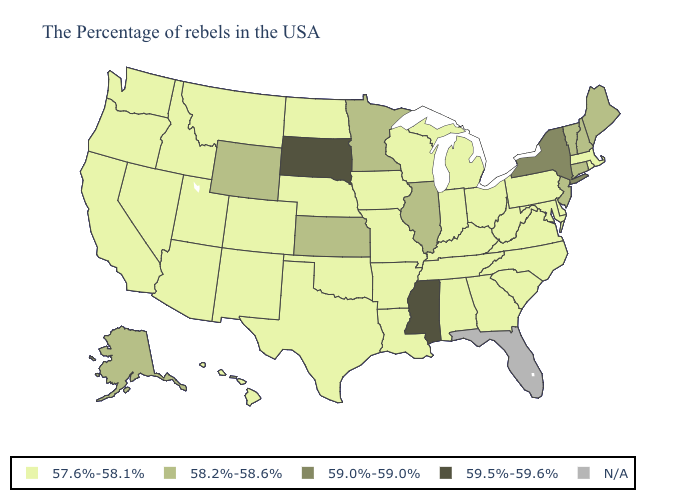What is the highest value in the USA?
Concise answer only. 59.5%-59.6%. What is the value of Arizona?
Quick response, please. 57.6%-58.1%. What is the value of Nebraska?
Short answer required. 57.6%-58.1%. Does New Hampshire have the lowest value in the USA?
Be succinct. No. Is the legend a continuous bar?
Keep it brief. No. Name the states that have a value in the range 59.0%-59.0%?
Concise answer only. New York. What is the value of Idaho?
Quick response, please. 57.6%-58.1%. Does South Dakota have the lowest value in the USA?
Answer briefly. No. What is the value of Minnesota?
Concise answer only. 58.2%-58.6%. Among the states that border Delaware , does Maryland have the lowest value?
Be succinct. Yes. Name the states that have a value in the range 58.2%-58.6%?
Write a very short answer. Maine, New Hampshire, Vermont, Connecticut, New Jersey, Illinois, Minnesota, Kansas, Wyoming, Alaska. How many symbols are there in the legend?
Quick response, please. 5. 